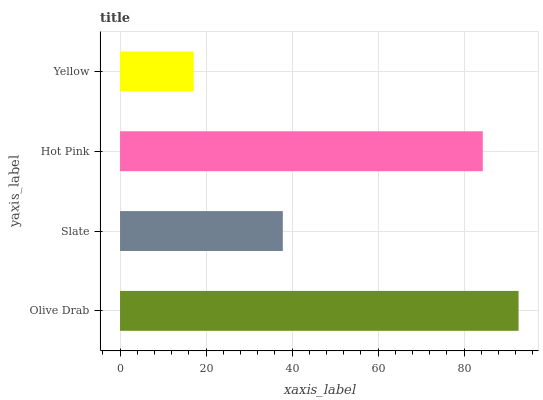Is Yellow the minimum?
Answer yes or no. Yes. Is Olive Drab the maximum?
Answer yes or no. Yes. Is Slate the minimum?
Answer yes or no. No. Is Slate the maximum?
Answer yes or no. No. Is Olive Drab greater than Slate?
Answer yes or no. Yes. Is Slate less than Olive Drab?
Answer yes or no. Yes. Is Slate greater than Olive Drab?
Answer yes or no. No. Is Olive Drab less than Slate?
Answer yes or no. No. Is Hot Pink the high median?
Answer yes or no. Yes. Is Slate the low median?
Answer yes or no. Yes. Is Slate the high median?
Answer yes or no. No. Is Yellow the low median?
Answer yes or no. No. 